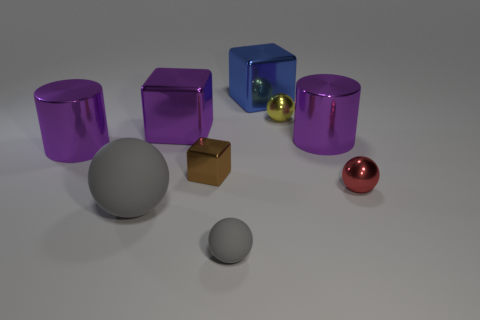Add 1 red metallic cylinders. How many objects exist? 10 Subtract all large balls. How many balls are left? 3 Subtract all yellow spheres. Subtract all yellow balls. How many objects are left? 7 Add 4 purple cubes. How many purple cubes are left? 5 Add 9 big blue things. How many big blue things exist? 10 Subtract all brown blocks. How many blocks are left? 2 Subtract 0 green cubes. How many objects are left? 9 Subtract all cylinders. How many objects are left? 7 Subtract 1 cylinders. How many cylinders are left? 1 Subtract all gray cylinders. Subtract all yellow spheres. How many cylinders are left? 2 